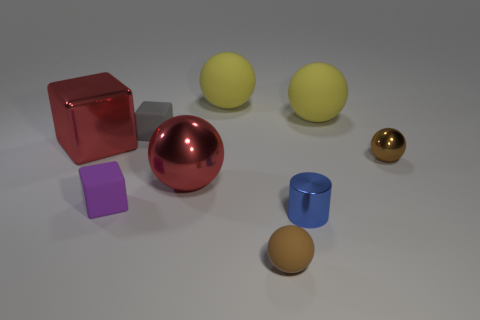Are there any other things that are the same material as the purple thing? Yes, the large red sphere and the small golden sphere seem to be made of the same glossy material as the purple cube. 